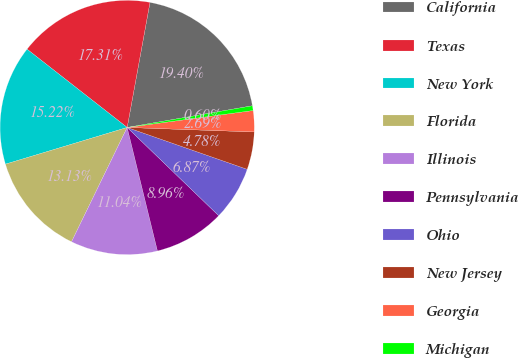<chart> <loc_0><loc_0><loc_500><loc_500><pie_chart><fcel>California<fcel>Texas<fcel>New York<fcel>Florida<fcel>Illinois<fcel>Pennsylvania<fcel>Ohio<fcel>New Jersey<fcel>Georgia<fcel>Michigan<nl><fcel>19.4%<fcel>17.31%<fcel>15.22%<fcel>13.13%<fcel>11.04%<fcel>8.96%<fcel>6.87%<fcel>4.78%<fcel>2.69%<fcel>0.6%<nl></chart> 